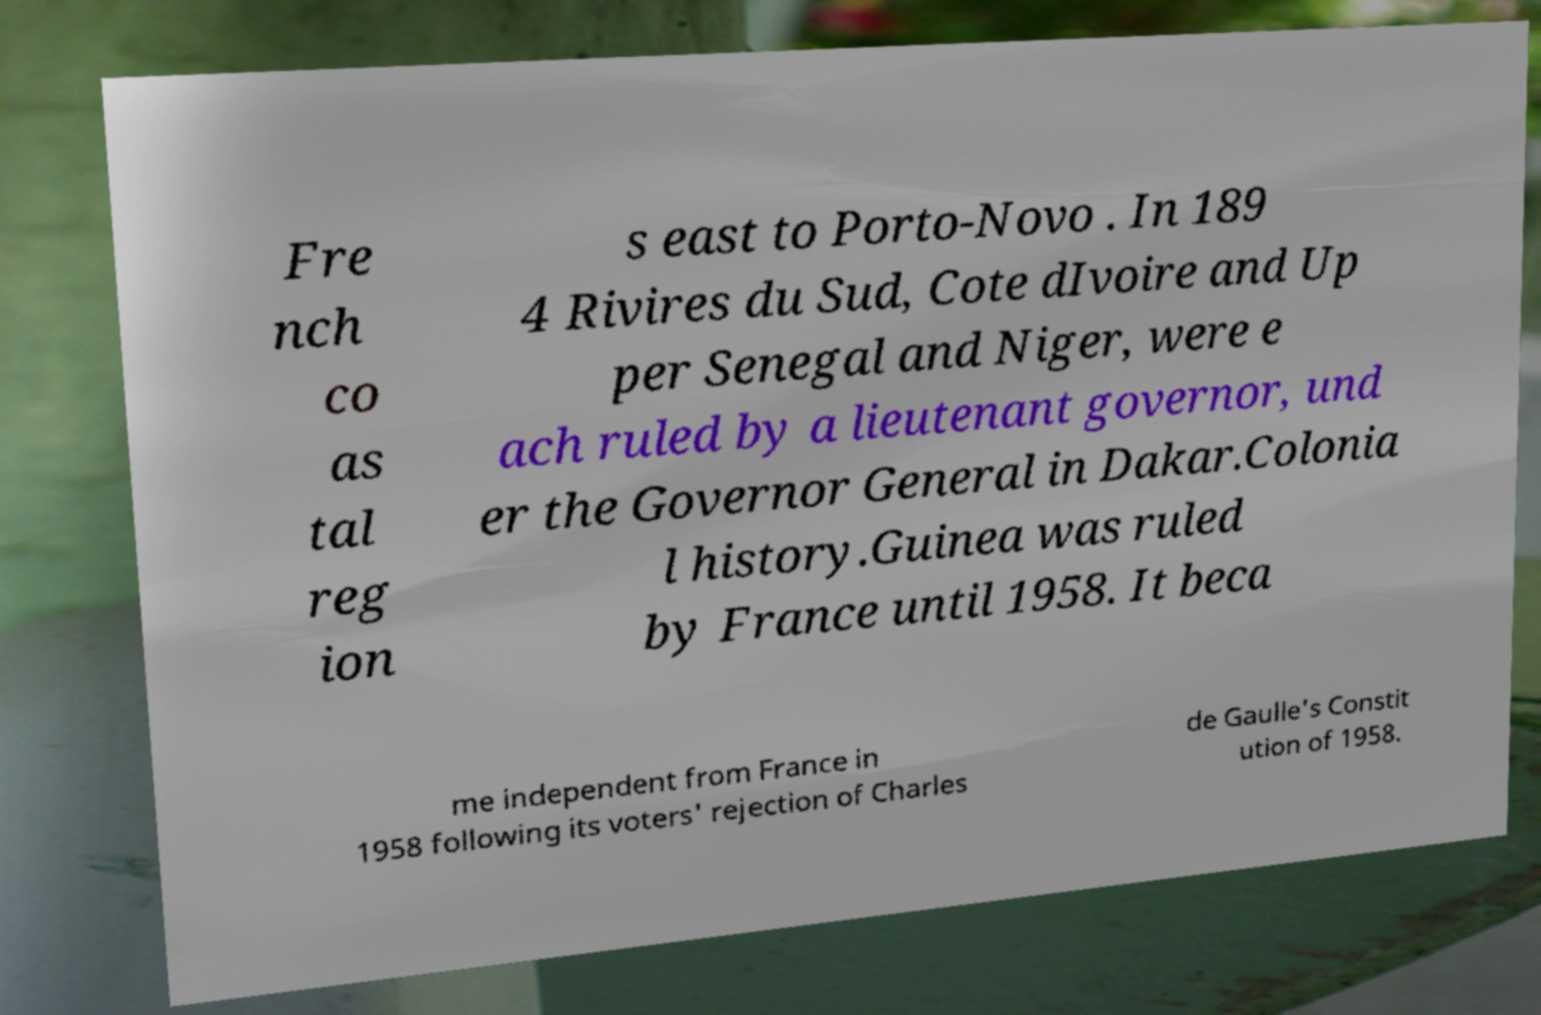Can you accurately transcribe the text from the provided image for me? Fre nch co as tal reg ion s east to Porto-Novo . In 189 4 Rivires du Sud, Cote dIvoire and Up per Senegal and Niger, were e ach ruled by a lieutenant governor, und er the Governor General in Dakar.Colonia l history.Guinea was ruled by France until 1958. It beca me independent from France in 1958 following its voters' rejection of Charles de Gaulle's Constit ution of 1958. 